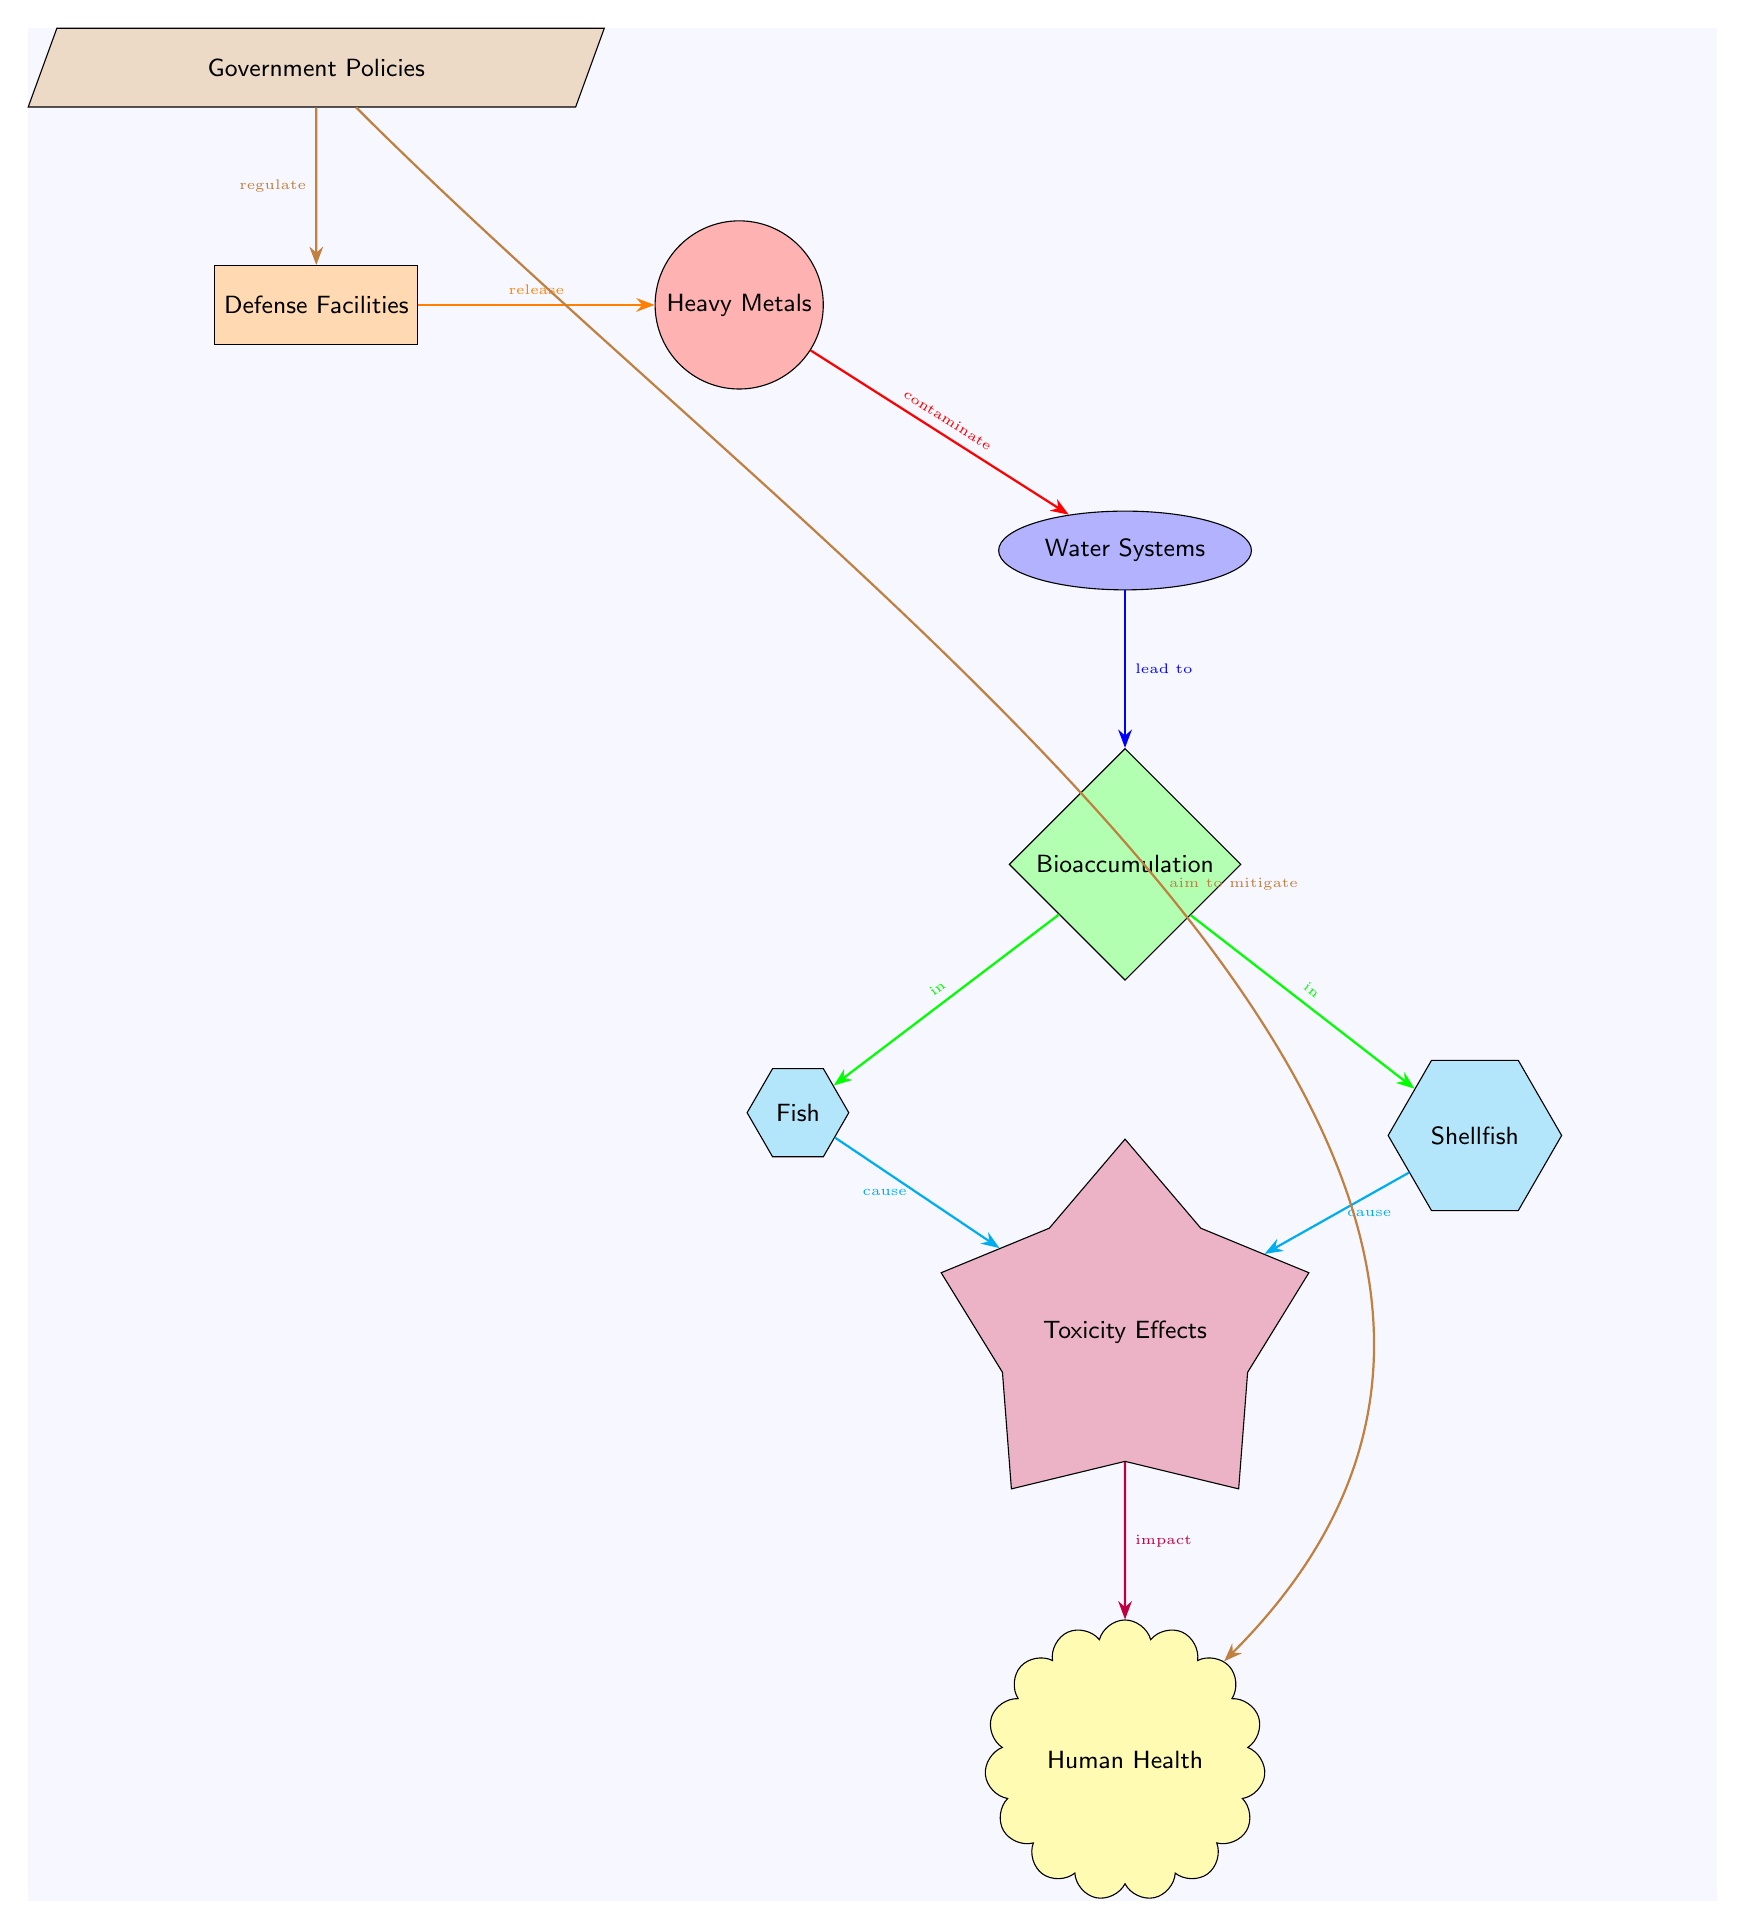What contaminant is associated with defense facilities? The diagram shows "Heavy Metals" as the contaminant linked to the node "Defense Facilities." The arrow indicates the release of heavy metals from these facilities.
Answer: Heavy Metals What aquatic life is affected by bioaccumulation? The diagram indicates that both "Fish" and "Shellfish" are impacted by the process of bioaccumulation, as they are represented as nodes connected to the "Bioaccumulation" process.
Answer: Fish and Shellfish How do government policies relate to the defense facilities? The diagram shows that "Government Policies" have a direct connection to "Defense Facilities," indicating that these policies aim to regulate the activities of the defense sector.
Answer: Regulate What is the end impact of toxicity effects according to the diagram? The "Toxicity Effects" node leads to the "Human Health" node, showing that toxicity from contaminated aquatic life ultimately affects human health.
Answer: Human Health How many nodes represent aquatic life in the diagram? The diagram displays two nodes that represent aquatic life: "Fish" and "Shellfish." Counting these nodes gives a total of two.
Answer: 2 What is the relationship between heavy metals and water systems? The diagram illustrates that heavy metals are shown to "contaminate" water systems, indicating a direct interaction in the pollution pathway.
Answer: Contaminate What is the process that follows bioaccumulation in aquatic life? Following bioaccumulation, both fish and shellfish cause "Toxicity Effects," which is illustrated by the directional arrows leading from the bioaccumulation process to the toxicity node.
Answer: Toxicity Effects How do government policies impact human health in this diagram? Government policies aim to mitigate the impact on human health by regulating defense activities, as shown by the connections in the diagram. This indicates a relationship that extends from policy to health.
Answer: Aim to mitigate What color represents the contaminant in the diagram? "Heavy Metals," which is the contaminant in this diagram, is represented by the color red, which fills the circular node.
Answer: Red 